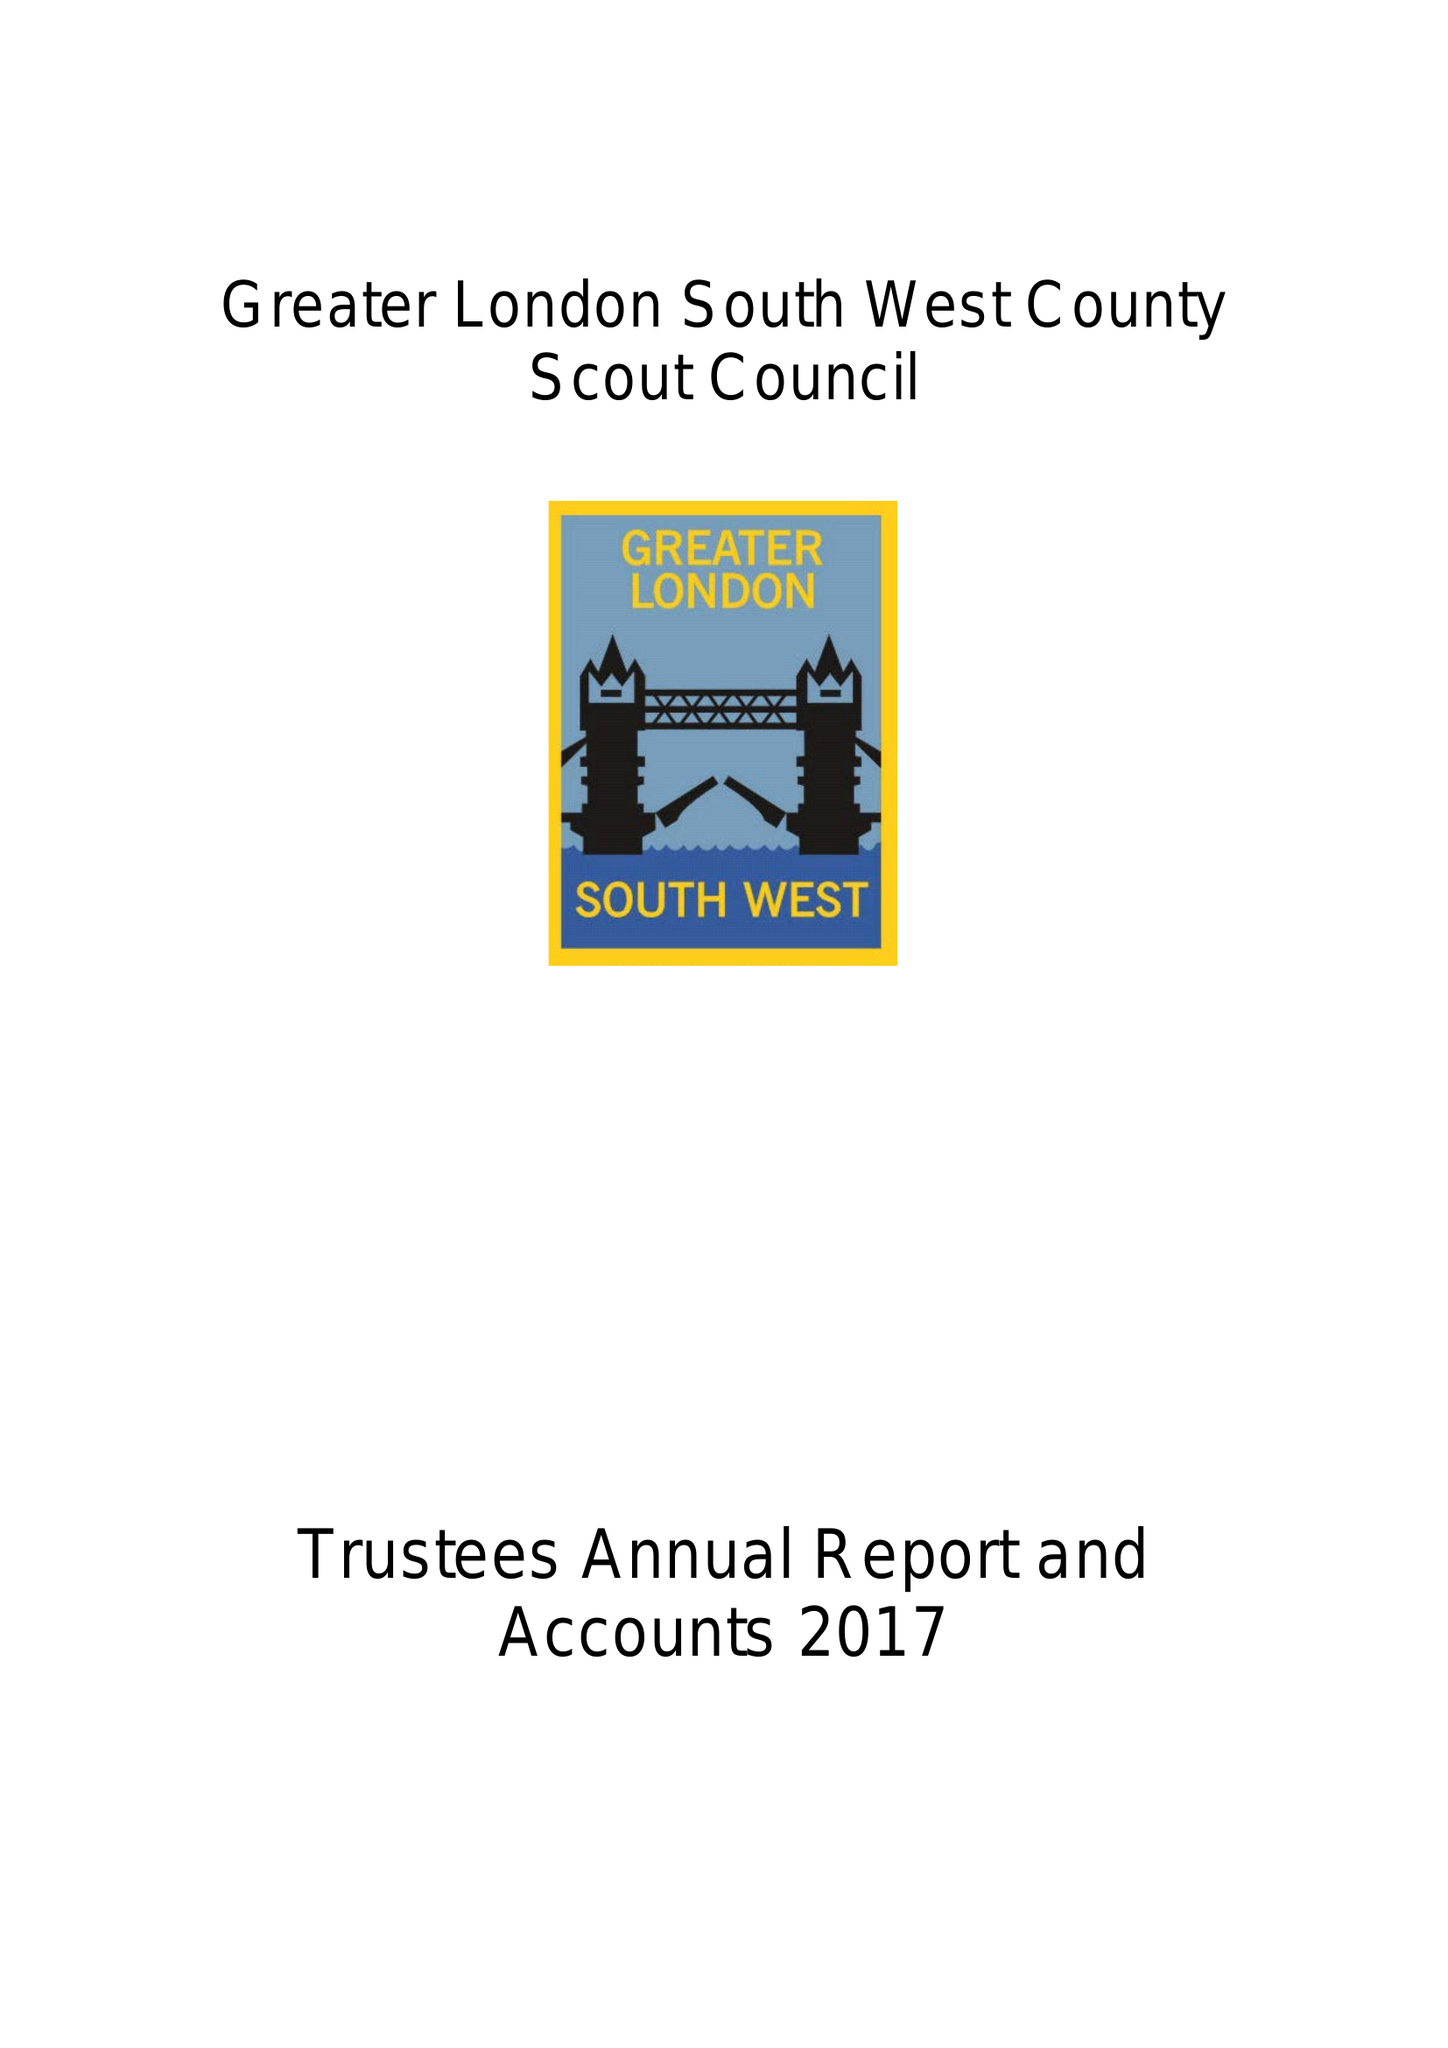What is the value for the income_annually_in_british_pounds?
Answer the question using a single word or phrase. 73641.00 